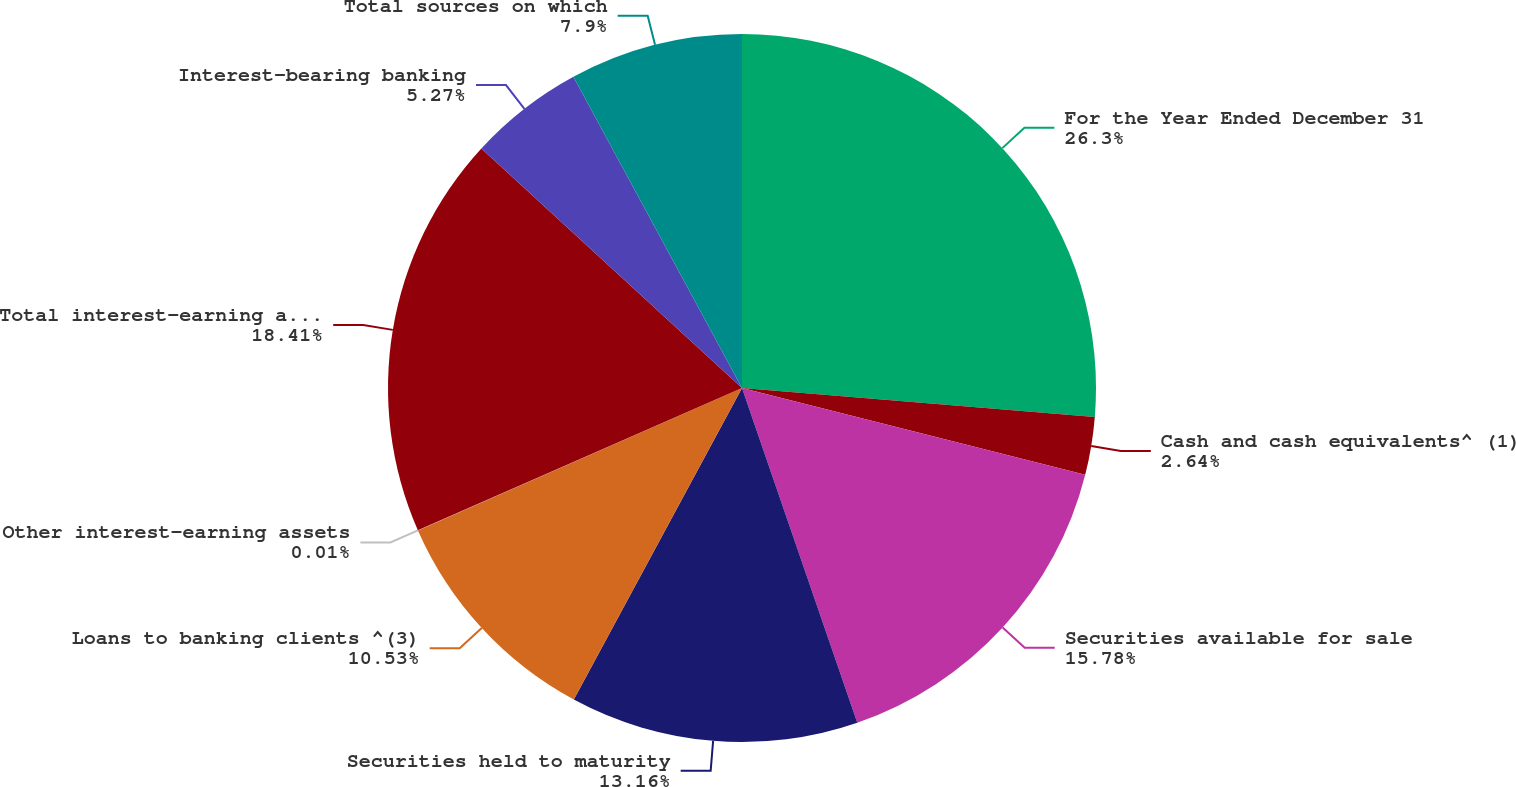Convert chart to OTSL. <chart><loc_0><loc_0><loc_500><loc_500><pie_chart><fcel>For the Year Ended December 31<fcel>Cash and cash equivalents^ (1)<fcel>Securities available for sale<fcel>Securities held to maturity<fcel>Loans to banking clients ^(3)<fcel>Other interest-earning assets<fcel>Total interest-earning assets<fcel>Interest-bearing banking<fcel>Total sources on which<nl><fcel>26.3%<fcel>2.64%<fcel>15.78%<fcel>13.16%<fcel>10.53%<fcel>0.01%<fcel>18.41%<fcel>5.27%<fcel>7.9%<nl></chart> 